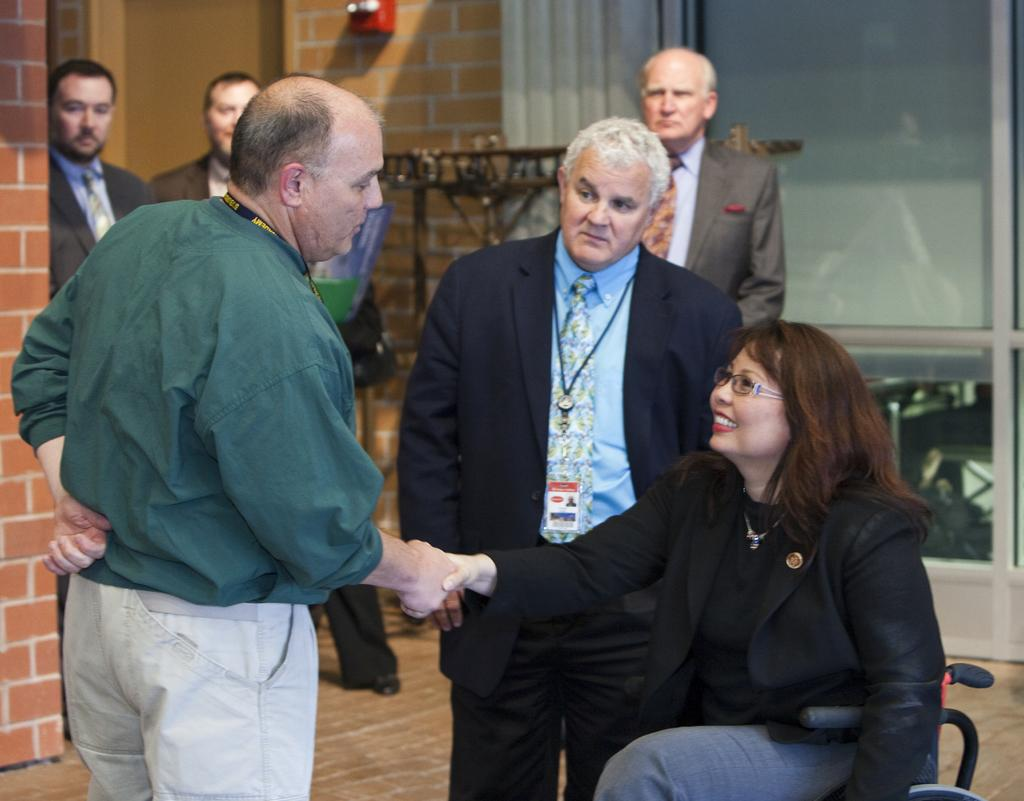What is happening in the image involving the people? There is a man and a woman shaking hands in the image. Can you describe the woman in the image? The woman is seated in a wheelchair. What can be inferred about the setting of the image? The image appears to be an indoor scene. How many fangs can be seen on the rail in the image? There is no rail or fangs present in the image. 